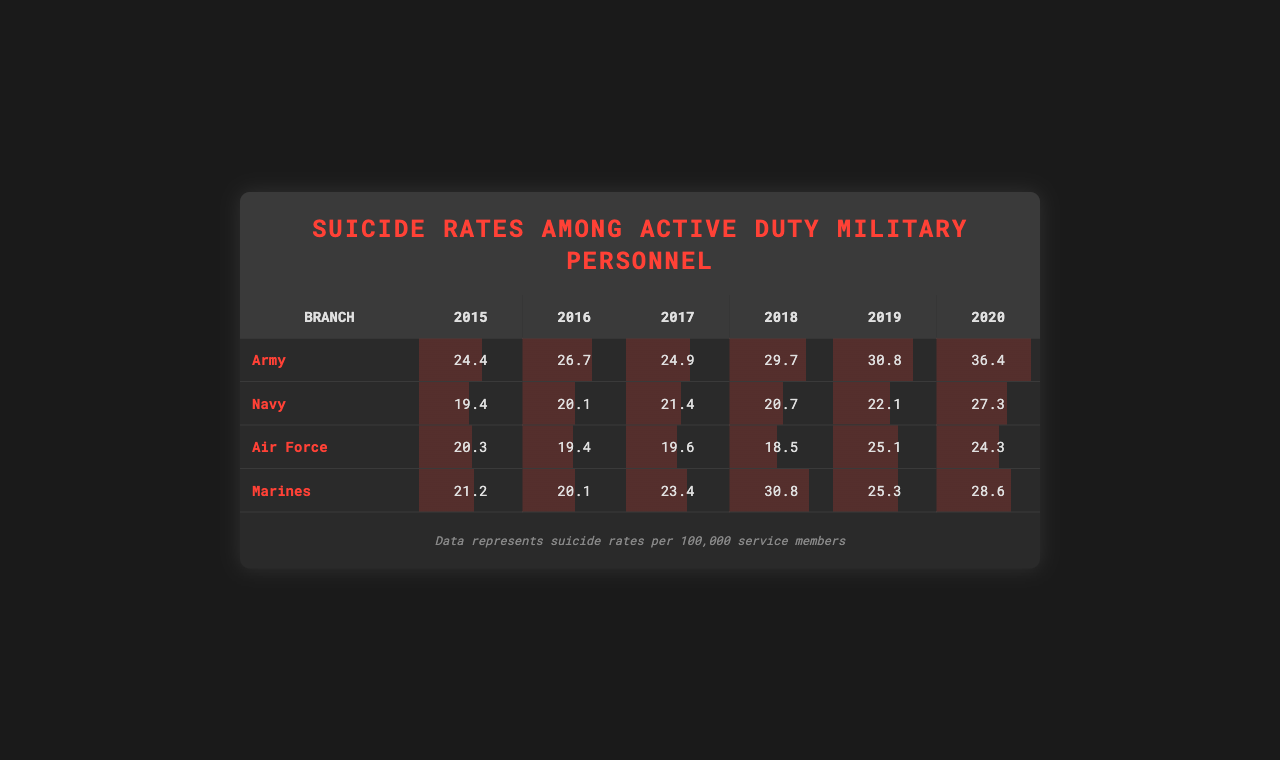What was the suicide rate for the Army in 2019? The suicide rate for the Army in 2019 is found in the Army row and the year 2019 column, which shows 30.8 per 100,000 service members.
Answer: 30.8 Which branch had the highest suicide rate in 2020? To find the branch with the highest suicide rate in 2020, we look at the column for 2020 and compare the values: Army (36.4), Navy (27.3), Air Force (24.3), and Marines (28.6). The Army has the highest rate at 36.4.
Answer: Army What was the average suicide rate for the Navy from 2015 to 2020? The Navy suicide rates from 2015 to 2020 are 19.4, 20.1, 21.4, 20.7, 22.1, and 27.3. To find the average, we sum these values: 19.4 + 20.1 + 21.4 + 20.7 + 22.1 + 27.3 = 131.0. Then, we divide by the number of years (6): 131.0 / 6 = 21.83.
Answer: 21.83 Did the suicide rate for the Air Force increase from 2018 to 2019? We compare the Air Force rates in 2018 (18.5) and 2019 (25.1). Since 25.1 is higher than 18.5, this indicates an increase.
Answer: Yes What is the total number of suicides per 100,000 in 2017 across all branches? We add the suicide rates for all branches in 2017: Army (24.9) + Navy (21.4) + Air Force (19.6) + Marines (23.4) = 89.3. This gives us the total number of suicides per 100,000 in 2017 across all branches.
Answer: 89.3 What was the change in the Army's suicide rate from 2015 to 2020? The Army's suicide rate in 2015 was 24.4 and in 2020 it was 36.4. To find the change, we subtract the earlier value from the later value: 36.4 - 24.4 = 12.0. This indicates an increase of 12.0 per 100,000.
Answer: 12.0 Which years did the Marines see a suicide rate higher than 25? We examine the Marines' rates: 21.2 (2015), 20.1 (2016), 23.4 (2017), 30.8 (2018), 25.3 (2019), and 28.6 (2020). Rates higher than 25 were recorded in 2018 (30.8), 2019 (25.3), and 2020 (28.6).
Answer: 2018, 2019, 2020 Which branch had the lowest average suicide rate over the years? We calculate the average rates for each branch: Army (29.2), Navy (20.6), Air Force (21.3), and Marines (24.6). The Navy has the lowest average at 20.6.
Answer: Navy 